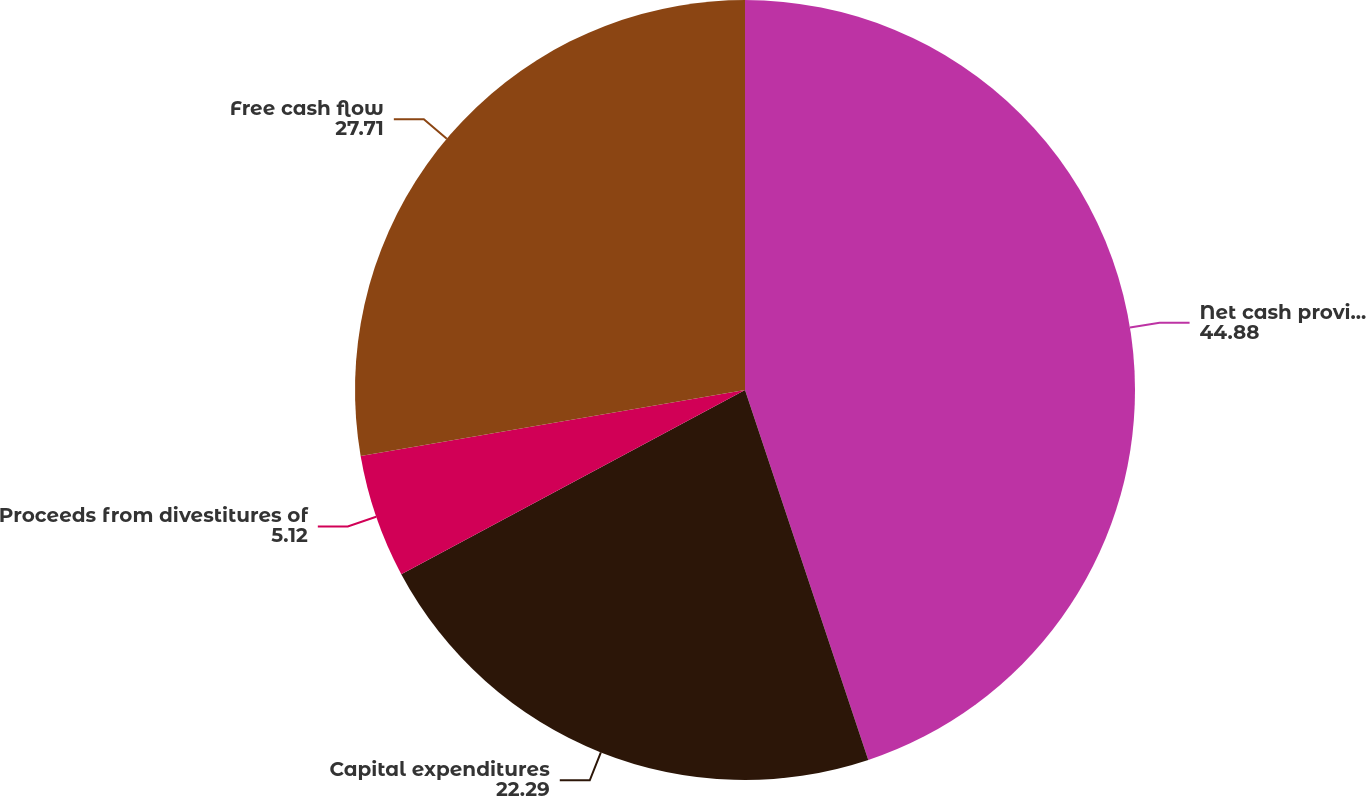Convert chart to OTSL. <chart><loc_0><loc_0><loc_500><loc_500><pie_chart><fcel>Net cash provided by operating<fcel>Capital expenditures<fcel>Proceeds from divestitures of<fcel>Free cash flow<nl><fcel>44.88%<fcel>22.29%<fcel>5.12%<fcel>27.71%<nl></chart> 